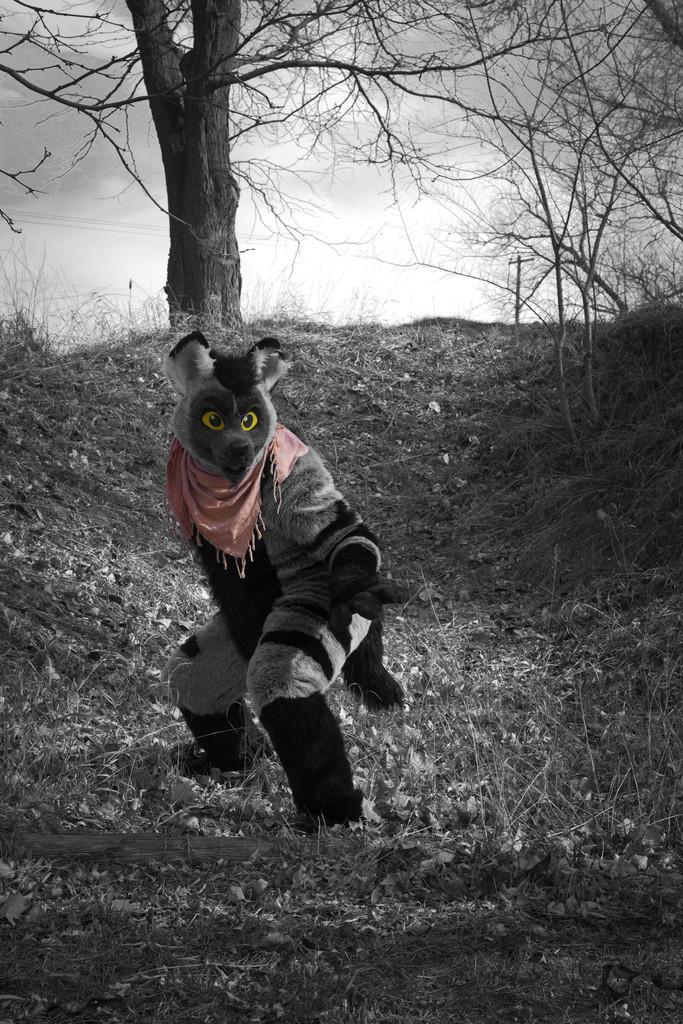How would you summarize this image in a sentence or two? In this picture we can see a person wearing an animal costume and standing on the grass surrounded by trees. 